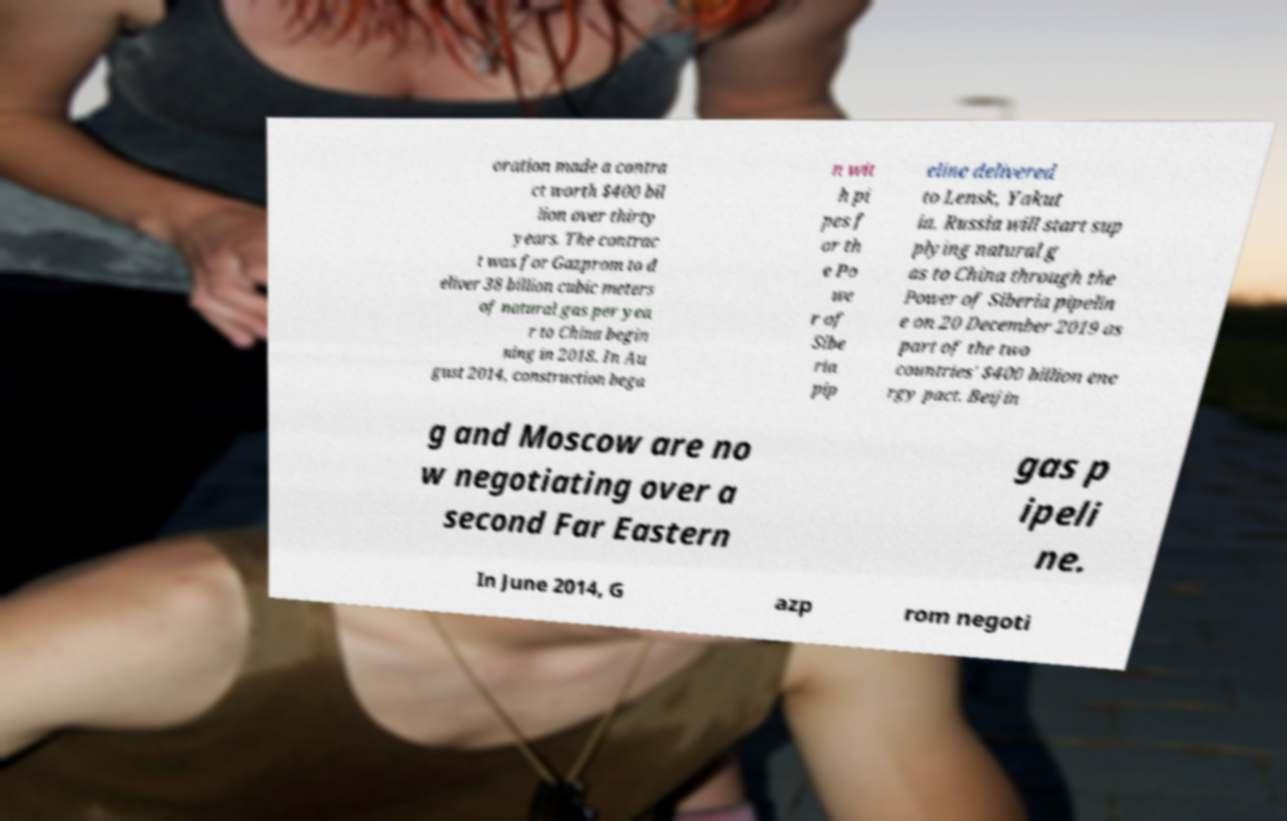Could you assist in decoding the text presented in this image and type it out clearly? oration made a contra ct worth $400 bil lion over thirty years. The contrac t was for Gazprom to d eliver 38 billion cubic meters of natural gas per yea r to China begin ning in 2018. In Au gust 2014, construction bega n wit h pi pes f or th e Po we r of Sibe ria pip eline delivered to Lensk, Yakut ia. Russia will start sup plying natural g as to China through the Power of Siberia pipelin e on 20 December 2019 as part of the two countries' $400 billion ene rgy pact. Beijin g and Moscow are no w negotiating over a second Far Eastern gas p ipeli ne. In June 2014, G azp rom negoti 